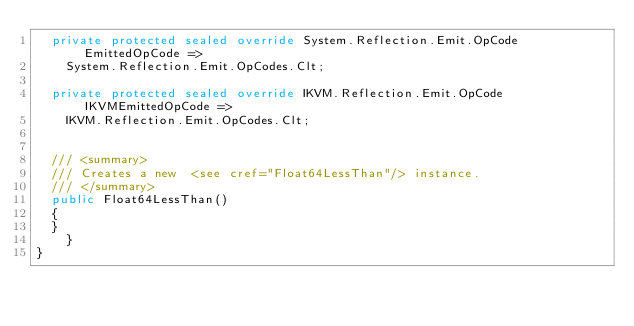<code> <loc_0><loc_0><loc_500><loc_500><_C#_>	private protected sealed override System.Reflection.Emit.OpCode EmittedOpCode =>
		System.Reflection.Emit.OpCodes.Clt;

	private protected sealed override IKVM.Reflection.Emit.OpCode IKVMEmittedOpCode =>
		IKVM.Reflection.Emit.OpCodes.Clt;


	/// <summary>
	/// Creates a new  <see cref="Float64LessThan"/> instance.
	/// </summary>
	public Float64LessThan()
	{
	}
    }
}</code> 